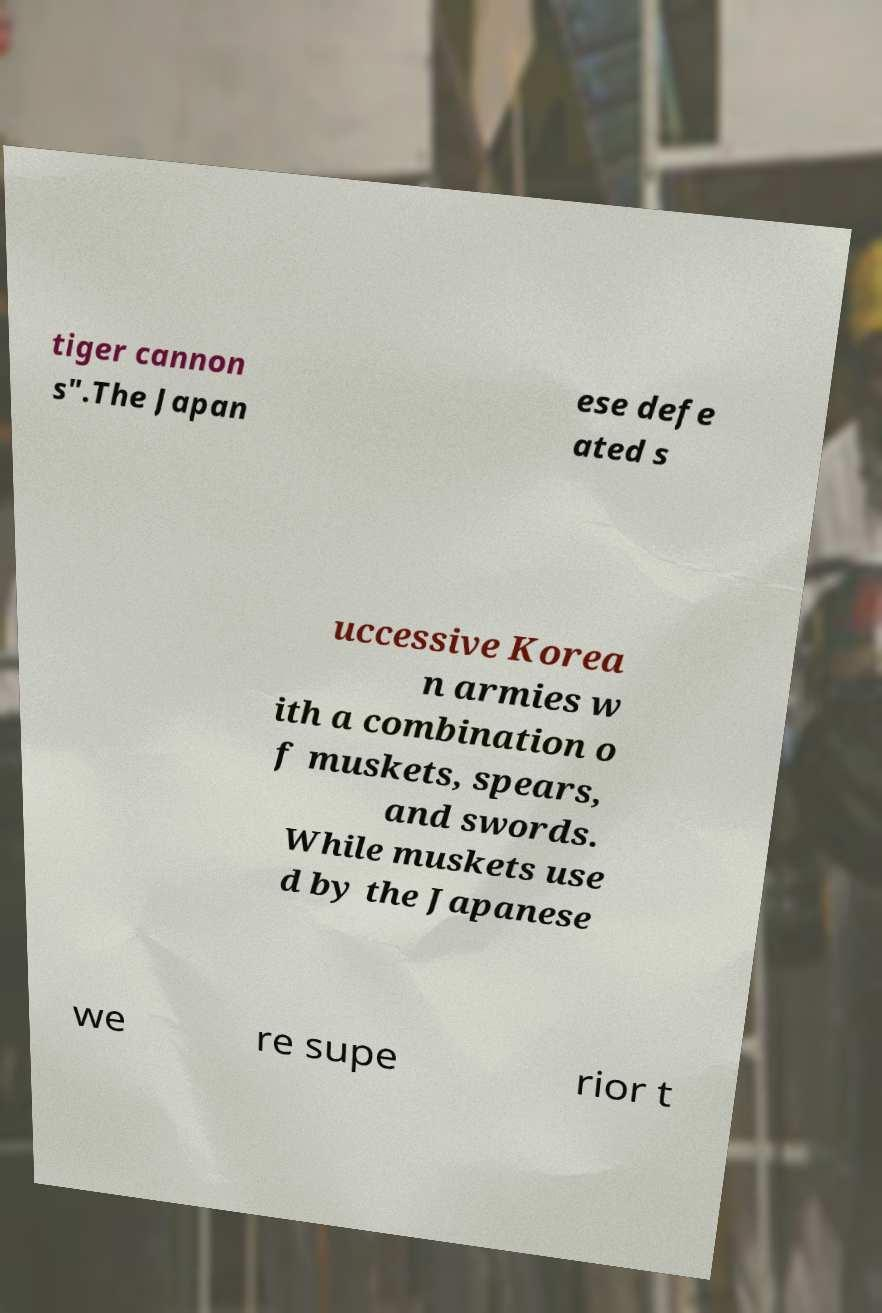Can you read and provide the text displayed in the image?This photo seems to have some interesting text. Can you extract and type it out for me? tiger cannon s".The Japan ese defe ated s uccessive Korea n armies w ith a combination o f muskets, spears, and swords. While muskets use d by the Japanese we re supe rior t 